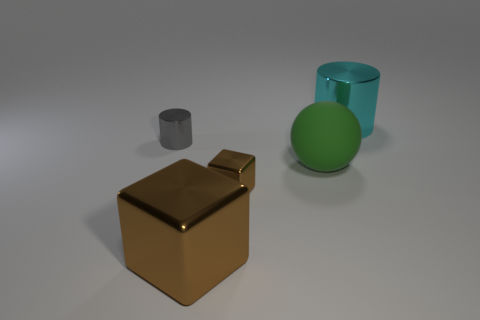Add 4 large red rubber things. How many objects exist? 9 Subtract all cubes. How many objects are left? 3 Subtract all large cyan shiny objects. Subtract all small gray metal cylinders. How many objects are left? 3 Add 4 big cyan metal objects. How many big cyan metal objects are left? 5 Add 1 large gray things. How many large gray things exist? 1 Subtract 1 brown cubes. How many objects are left? 4 